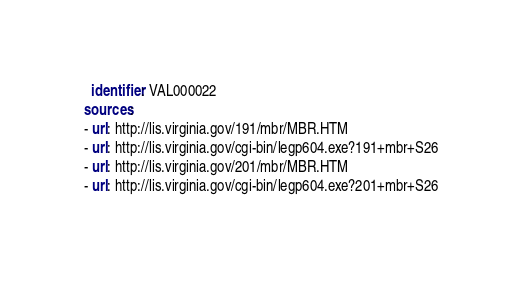Convert code to text. <code><loc_0><loc_0><loc_500><loc_500><_YAML_>  identifier: VAL000022
sources:
- url: http://lis.virginia.gov/191/mbr/MBR.HTM
- url: http://lis.virginia.gov/cgi-bin/legp604.exe?191+mbr+S26
- url: http://lis.virginia.gov/201/mbr/MBR.HTM
- url: http://lis.virginia.gov/cgi-bin/legp604.exe?201+mbr+S26
</code> 